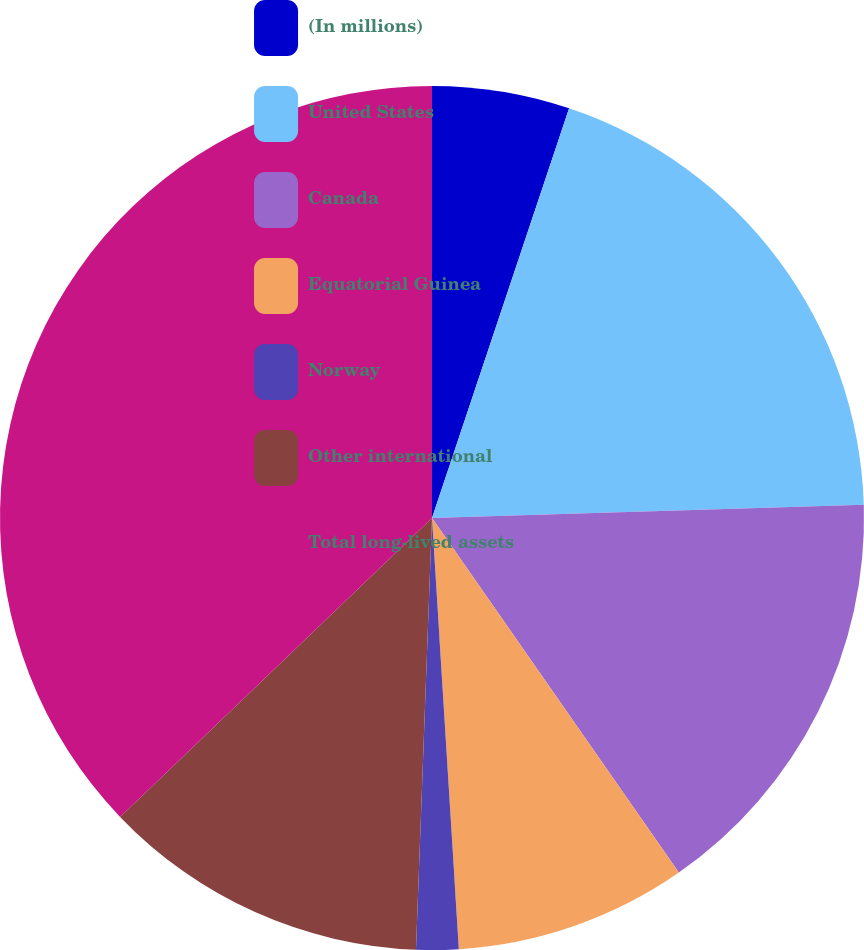<chart> <loc_0><loc_0><loc_500><loc_500><pie_chart><fcel>(In millions)<fcel>United States<fcel>Canada<fcel>Equatorial Guinea<fcel>Norway<fcel>Other international<fcel>Total long-lived assets<nl><fcel>5.14%<fcel>19.37%<fcel>15.81%<fcel>8.69%<fcel>1.58%<fcel>12.25%<fcel>37.16%<nl></chart> 